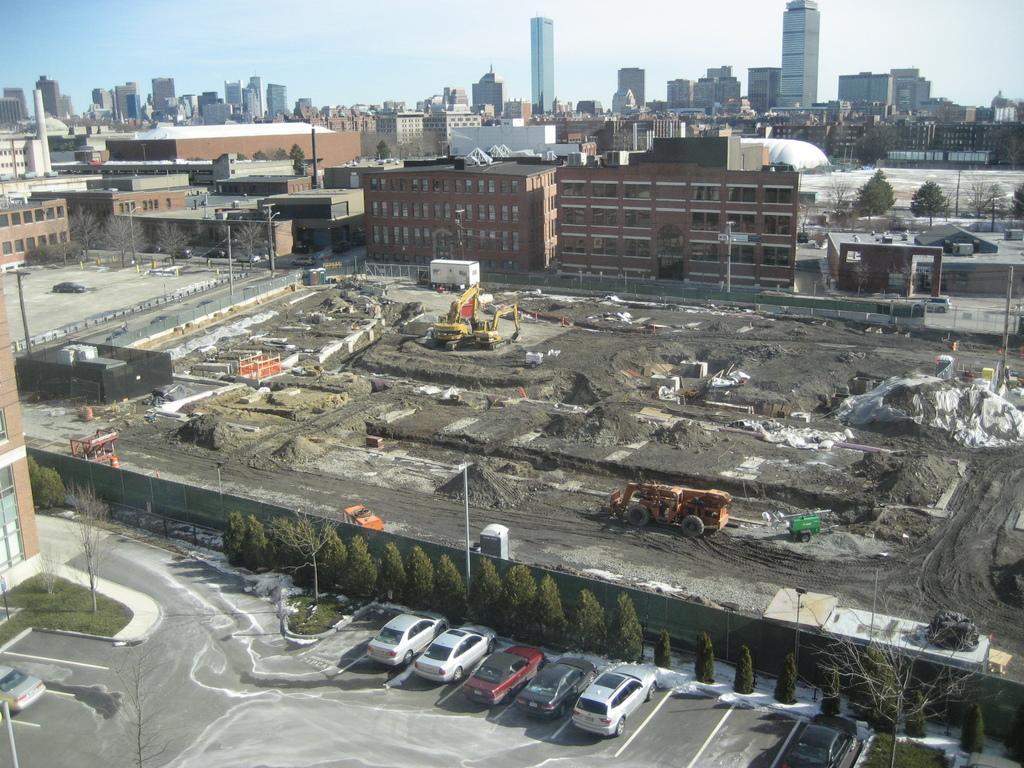Please provide a concise description of this image. In the image there are many buildings with walls and windows. There are few cranes and its look like a construction is going on. At the bottom of the image on the road there are few cars in a parking area and also there are few poles. There are many trees. At the top of the image there is a sky. 